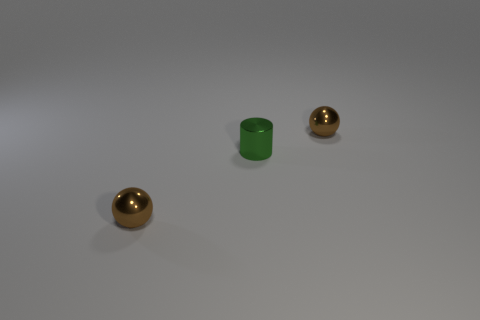Is there any other thing that is the same shape as the tiny green thing?
Provide a short and direct response. No. How many metal things are the same size as the metal cylinder?
Your answer should be compact. 2. Is the number of small brown things greater than the number of cylinders?
Your answer should be compact. Yes. There is a shiny thing that is in front of the green metallic thing that is in front of the shiny ball behind the tiny cylinder; what is its color?
Offer a very short reply. Brown. Are the small brown ball that is behind the tiny shiny cylinder and the tiny green cylinder made of the same material?
Provide a succinct answer. Yes. Are any small brown shiny blocks visible?
Your response must be concise. No. There is a brown sphere that is in front of the green metal cylinder; is it the same size as the green cylinder?
Make the answer very short. Yes. Is the number of tiny brown spheres less than the number of large red matte cylinders?
Make the answer very short. No. There is a tiny brown object to the left of the green object left of the small brown metallic sphere that is to the right of the small green cylinder; what shape is it?
Provide a short and direct response. Sphere. Are there any brown things that have the same material as the small green object?
Give a very brief answer. Yes. 